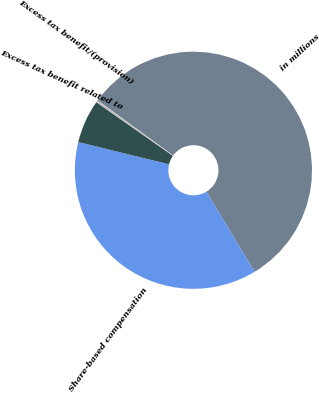<chart> <loc_0><loc_0><loc_500><loc_500><pie_chart><fcel>in millions<fcel>Share-based compensation<fcel>Excess tax benefit related to<fcel>Excess tax benefit/(provision)<nl><fcel>56.33%<fcel>37.46%<fcel>5.91%<fcel>0.31%<nl></chart> 